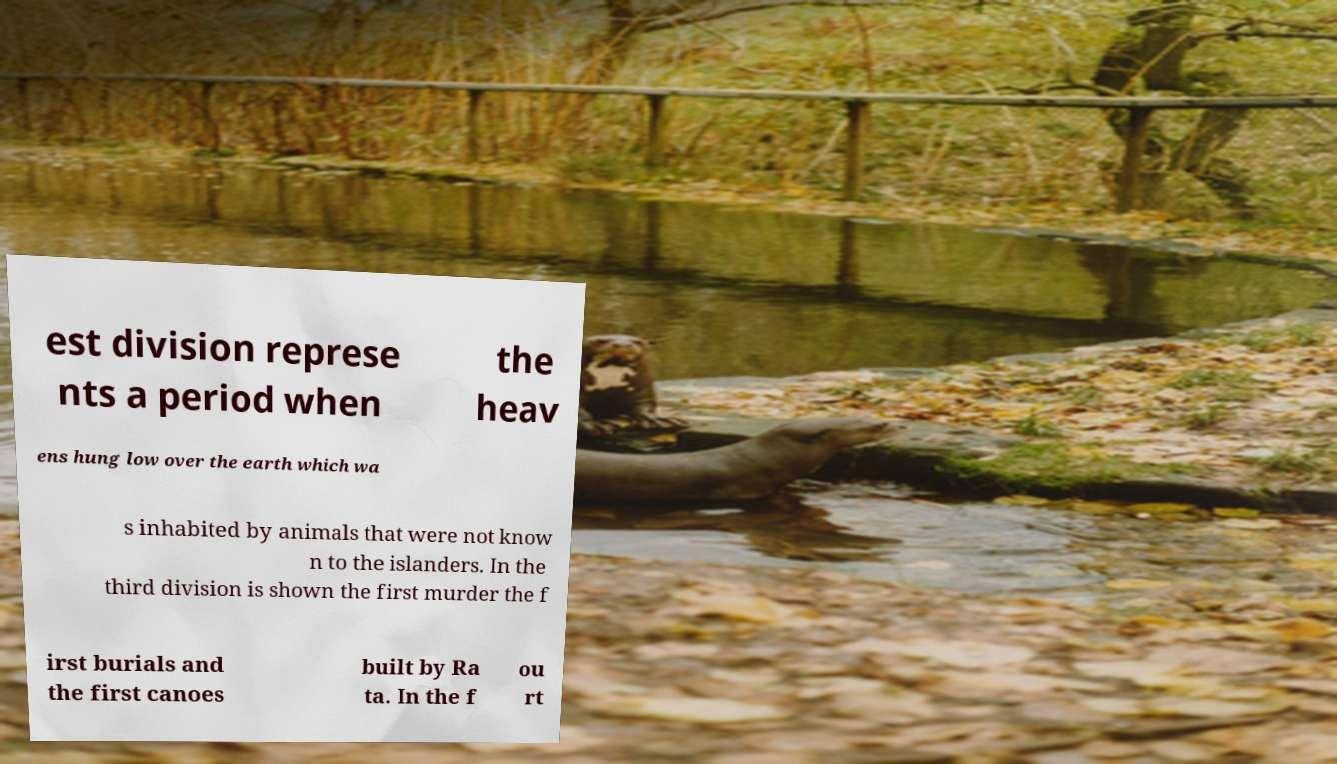Can you read and provide the text displayed in the image?This photo seems to have some interesting text. Can you extract and type it out for me? est division represe nts a period when the heav ens hung low over the earth which wa s inhabited by animals that were not know n to the islanders. In the third division is shown the first murder the f irst burials and the first canoes built by Ra ta. In the f ou rt 